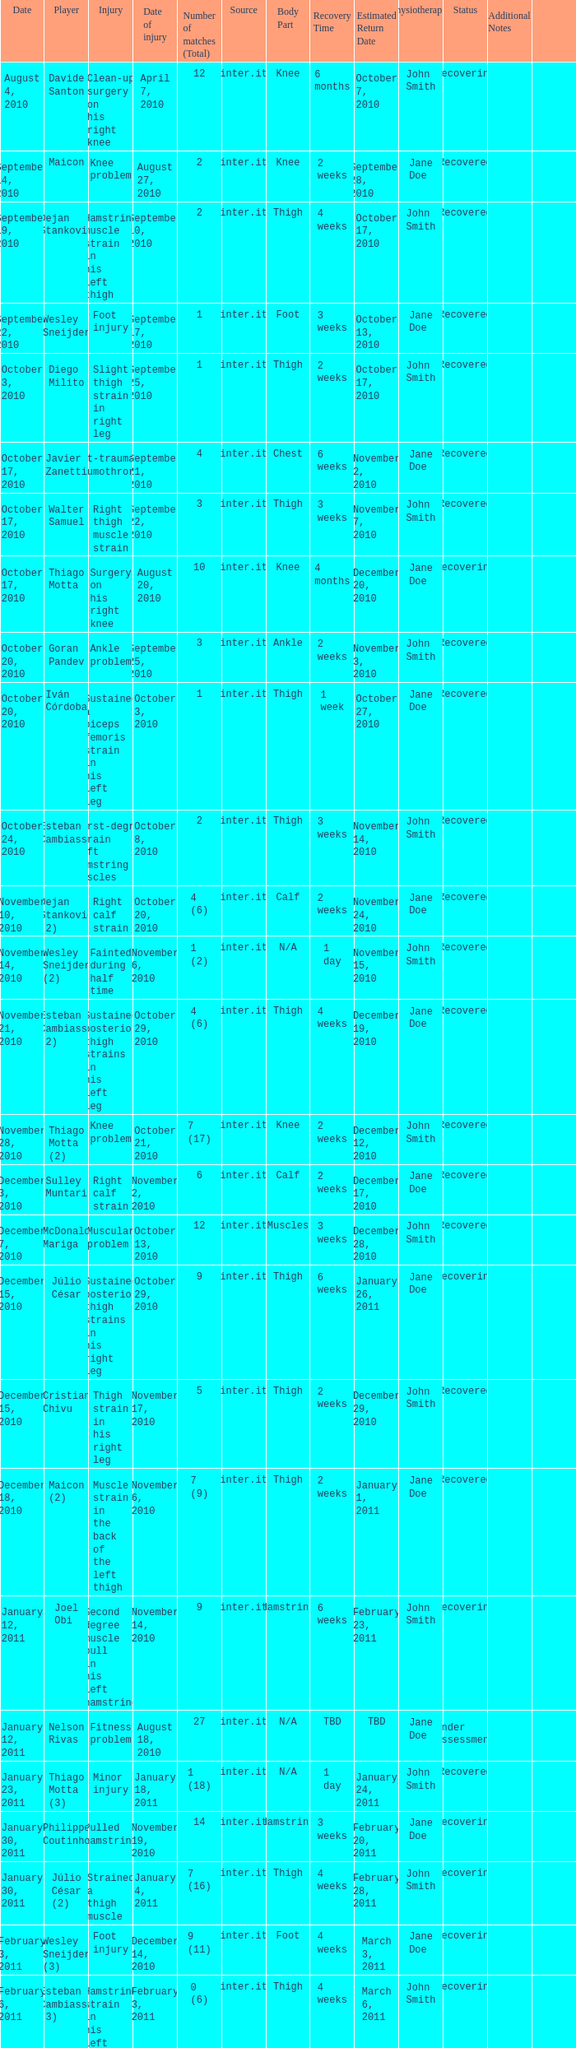How many times was the date october 3, 2010? 1.0. 